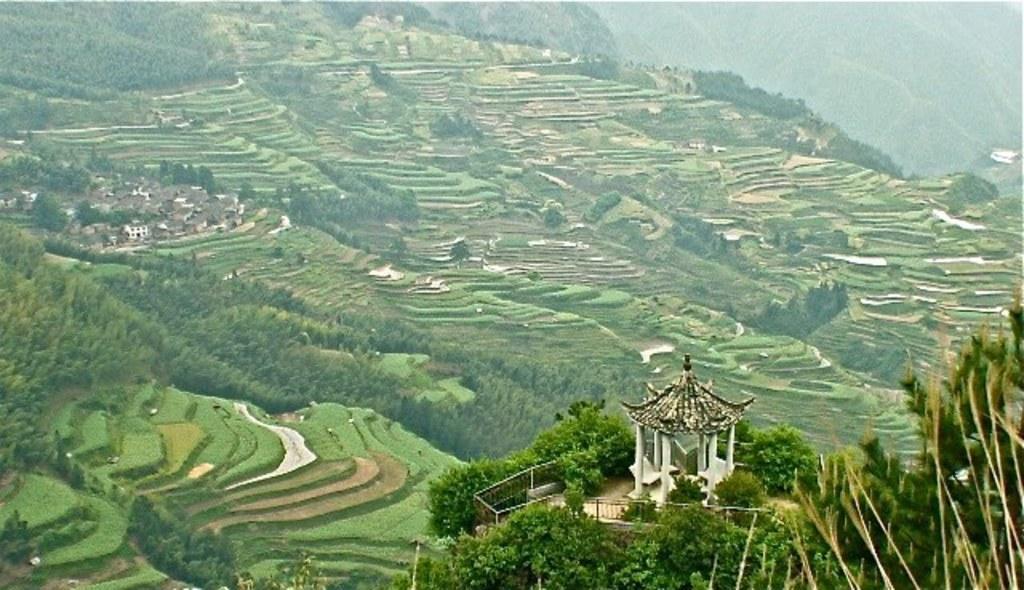Can you describe this image briefly? In this image we can see some fields, trees, buildings, plants, mountains and fence. 